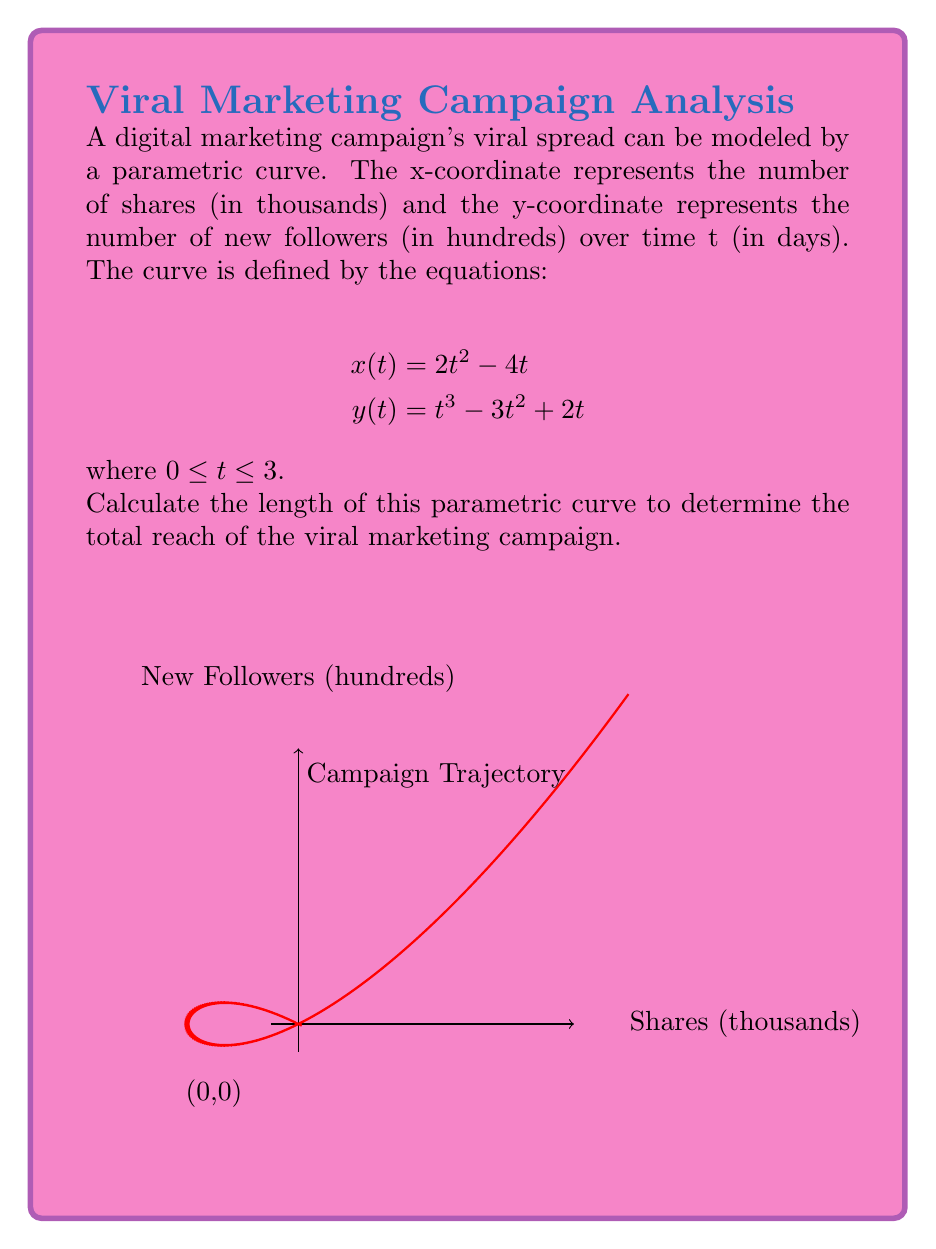Show me your answer to this math problem. To find the length of a parametric curve, we use the formula:

$$L = \int_{a}^{b} \sqrt{\left(\frac{dx}{dt}\right)^2 + \left(\frac{dy}{dt}\right)^2} dt$$

Step 1: Find $\frac{dx}{dt}$ and $\frac{dy}{dt}$
$$\frac{dx}{dt} = 4t - 4$$
$$\frac{dy}{dt} = 3t^2 - 6t + 2$$

Step 2: Substitute these into the formula
$$L = \int_{0}^{3} \sqrt{(4t - 4)^2 + (3t^2 - 6t + 2)^2} dt$$

Step 3: Simplify the expression under the square root
$$L = \int_{0}^{3} \sqrt{16t^2 - 32t + 16 + 9t^4 - 36t^3 + 54t^2 - 36t + 4} dt$$
$$L = \int_{0}^{3} \sqrt{9t^4 - 36t^3 + 70t^2 - 68t + 20} dt$$

Step 4: This integral cannot be solved analytically, so we need to use numerical integration methods. Using a computational tool or calculator with numerical integration capabilities, we can evaluate this integral.

Step 5: After numerical integration, we get:
$$L \approx 17.89$$

This means the length of the parametric curve representing the viral marketing campaign's trajectory is approximately 17.89 units.
Answer: $17.89$ units 